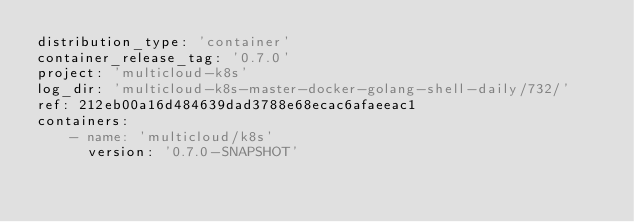<code> <loc_0><loc_0><loc_500><loc_500><_YAML_>distribution_type: 'container'
container_release_tag: '0.7.0'
project: 'multicloud-k8s'
log_dir: 'multicloud-k8s-master-docker-golang-shell-daily/732/'
ref: 212eb00a16d484639dad3788e68ecac6afaeeac1
containers:
    - name: 'multicloud/k8s'
      version: '0.7.0-SNAPSHOT'
</code> 